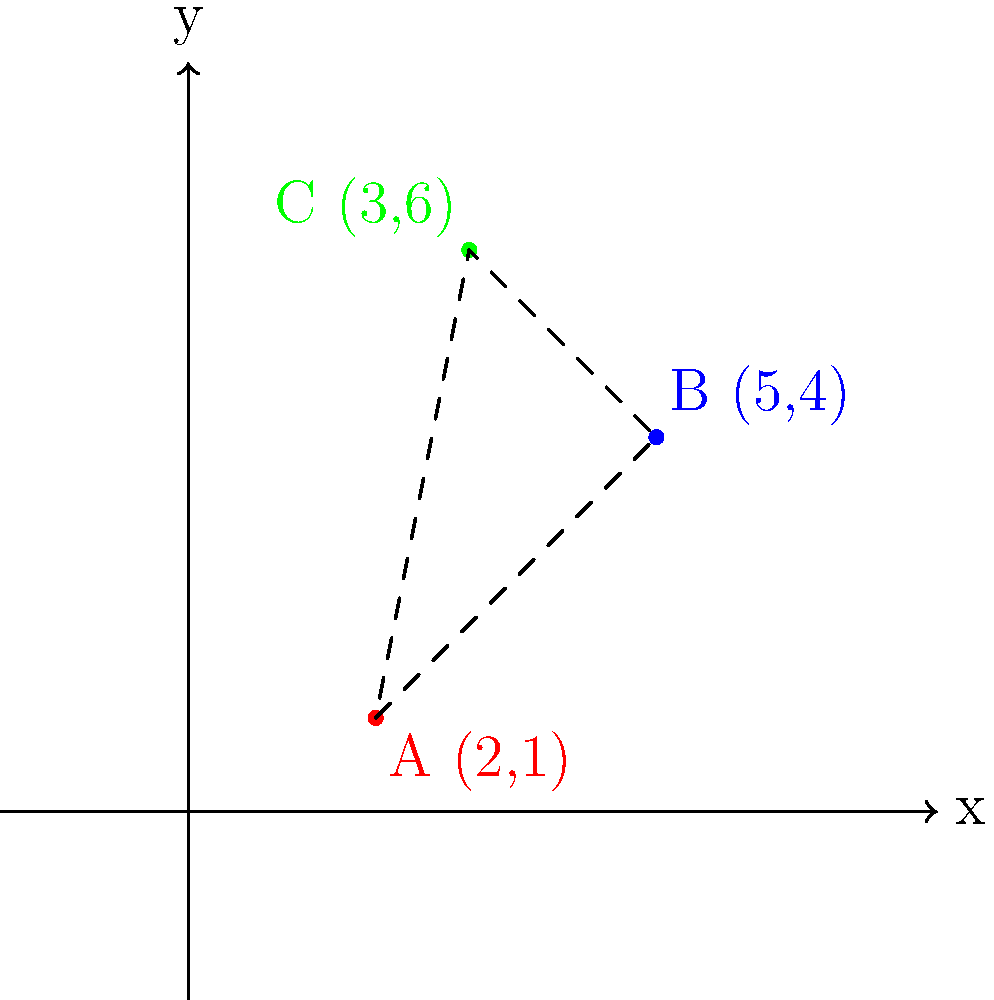In planning a literary walking tour of Notting Hill, you've mapped three key locations: A (2,1) for a famous author's home, B (5,4) for a historic bookshop, and C (3,6) for a notable literary café. To make the map more interesting, you decide to rotate all points 90° clockwise around the origin. What are the new coordinates of point B after this transformation? To solve this problem, we'll follow these steps:

1) Recall the formula for rotating a point $(x,y)$ by 90° clockwise around the origin:
   $$(x,y) \rightarrow (y,-x)$$

2) The original coordinates of point B are (5,4).

3) Apply the rotation formula:
   $x_{new} = y = 4$
   $y_{new} = -x = -5$

4) Therefore, the new coordinates of point B after rotation are (4,-5).

This transformation effectively rotates the entire triangle formed by points A, B, and C, creating a new perspective for the literary walking tour map of Notting Hill.
Answer: (4,-5) 